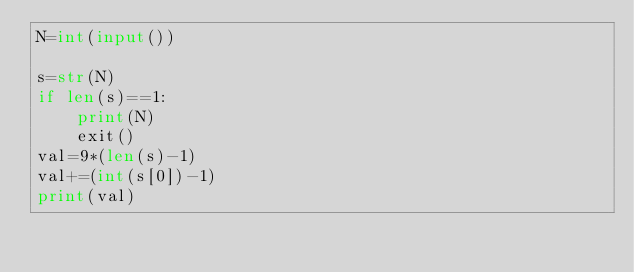<code> <loc_0><loc_0><loc_500><loc_500><_Python_>N=int(input())

s=str(N)
if len(s)==1:
    print(N)
    exit()
val=9*(len(s)-1)
val+=(int(s[0])-1)
print(val)</code> 